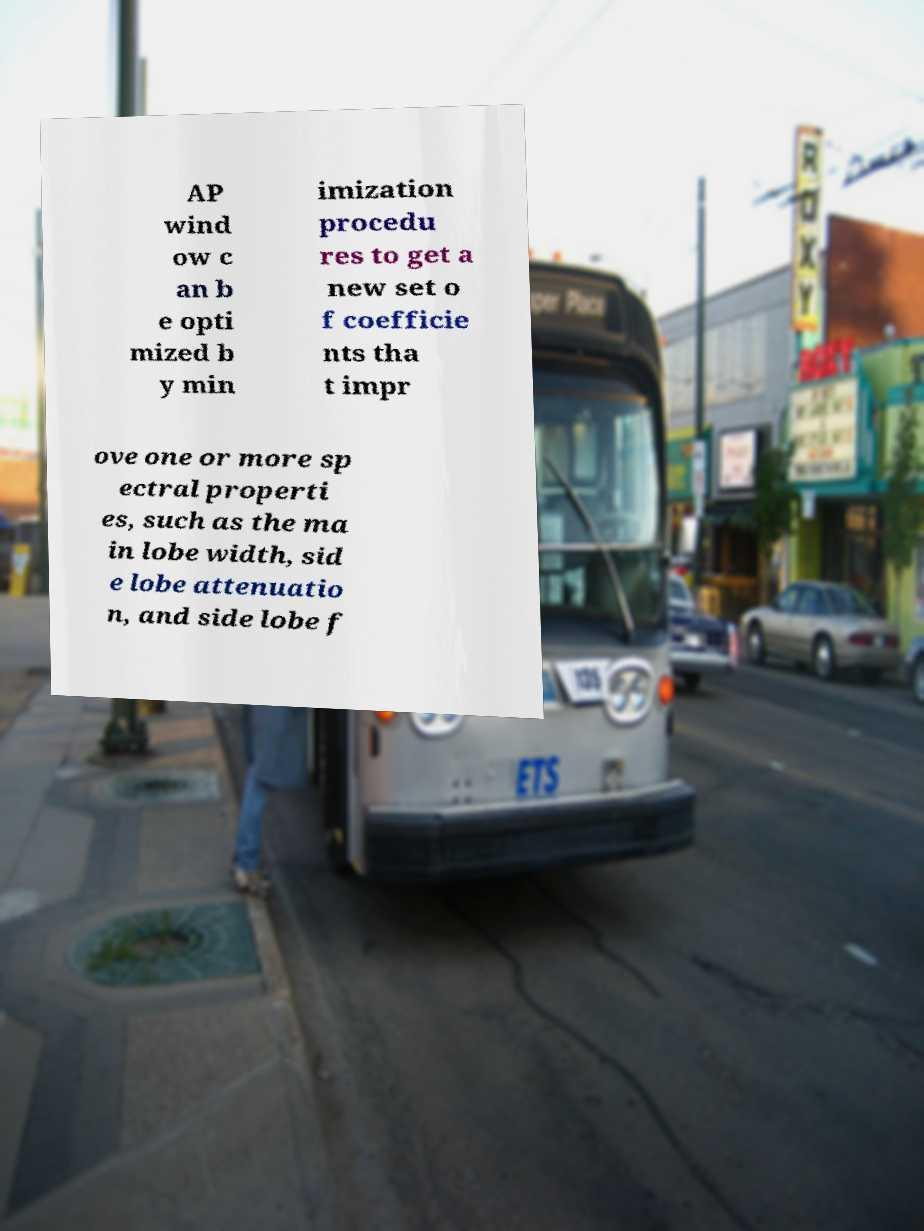Could you assist in decoding the text presented in this image and type it out clearly? AP wind ow c an b e opti mized b y min imization procedu res to get a new set o f coefficie nts tha t impr ove one or more sp ectral properti es, such as the ma in lobe width, sid e lobe attenuatio n, and side lobe f 